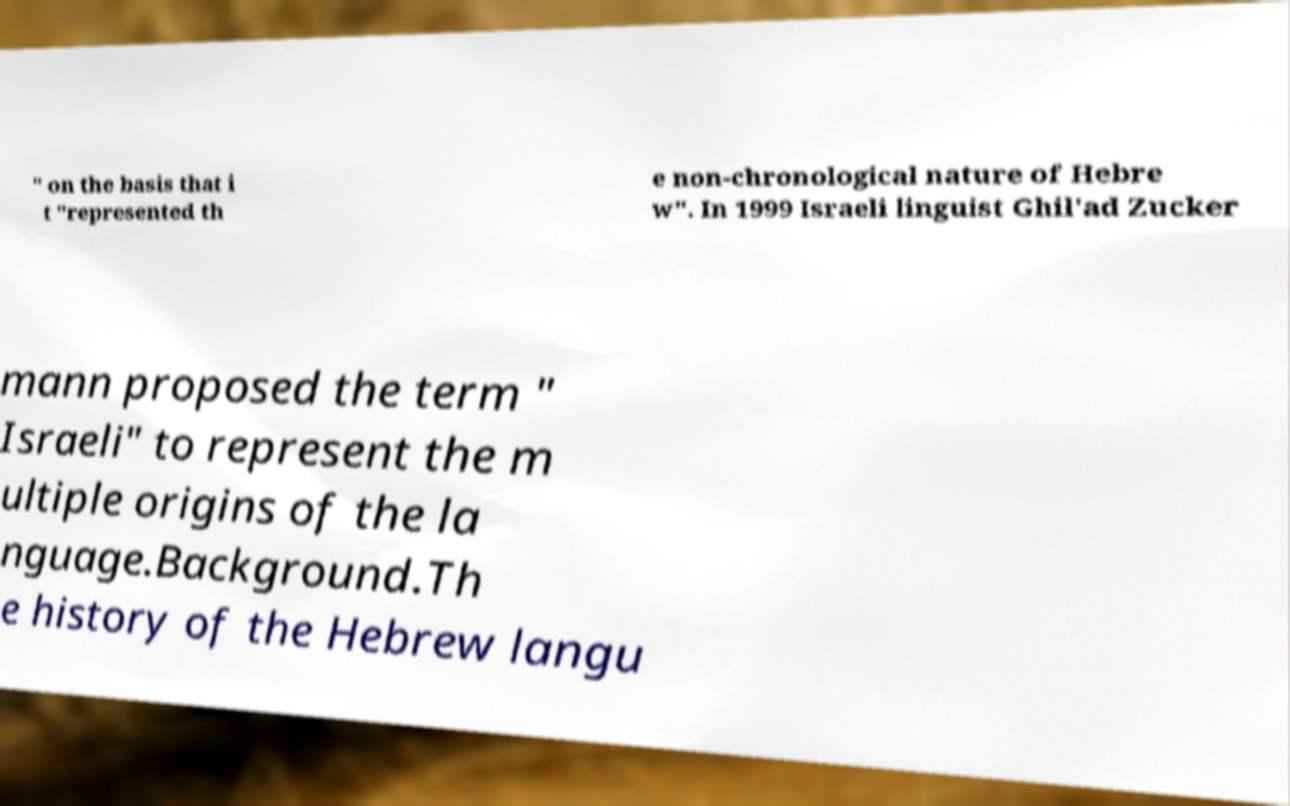Could you assist in decoding the text presented in this image and type it out clearly? " on the basis that i t "represented th e non-chronological nature of Hebre w". In 1999 Israeli linguist Ghil'ad Zucker mann proposed the term " Israeli" to represent the m ultiple origins of the la nguage.Background.Th e history of the Hebrew langu 